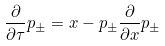<formula> <loc_0><loc_0><loc_500><loc_500>\frac { \partial } { \partial \tau } p _ { \pm } = x - p _ { \pm } \frac { \partial } { \partial x } p _ { \pm }</formula> 